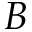<formula> <loc_0><loc_0><loc_500><loc_500>B</formula> 